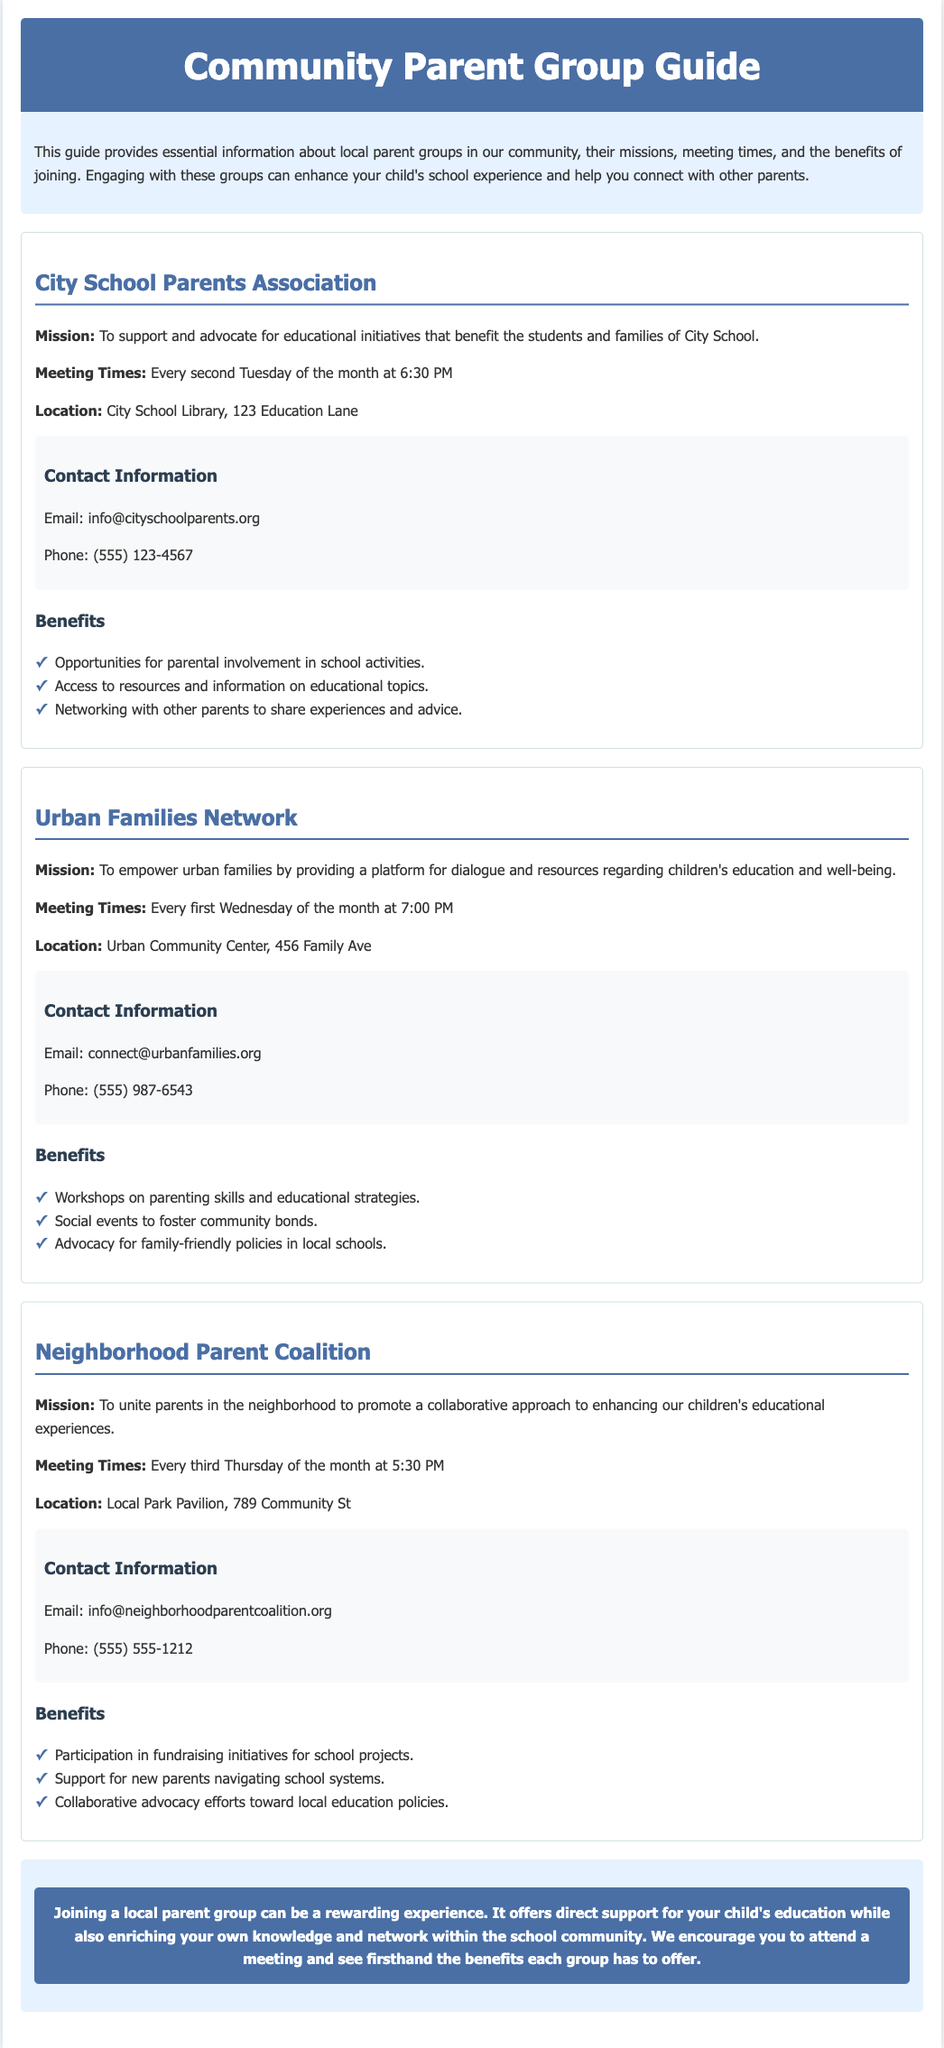What is the mission of the City School Parents Association? The mission of the City School Parents Association is to support and advocate for educational initiatives that benefit the students and families of City School.
Answer: To support and advocate for educational initiatives When does the Urban Families Network meet? The meeting time for the Urban Families Network is specified as every first Wednesday of the month at 7:00 PM.
Answer: Every first Wednesday of the month at 7:00 PM What is the location of the Neighborhood Parent Coalition? The location of the Neighborhood Parent Coalition meetings is mentioned in the document as Local Park Pavilion, 789 Community St.
Answer: Local Park Pavilion, 789 Community St How many benefits are listed for the City School Parents Association? The document lists three benefits for the City School Parents Association in the benefits section.
Answer: Three What is a shared benefit of joining any local parent group? The document highlights that joining a local parent group can enhance your child's school experience and help you connect with other parents as a shared benefit.
Answer: Enhance your child's school experience What is the contact email for the Urban Families Network? The contact email for the Urban Families Network is provided in the contact information section.
Answer: connect@urbanfamilies.org Which groups meet on Thursdays? The document states that the Neighborhood Parent Coalition meets every third Thursday of the month at 5:30 PM, so this is the group that meets on Thursdays.
Answer: Neighborhood Parent Coalition What type of events does the Urban Families Network host? The Urban Families Network hosts workshops on parenting skills and educational strategies, mentioned in the benefits section.
Answer: Workshops on parenting skills and educational strategies 